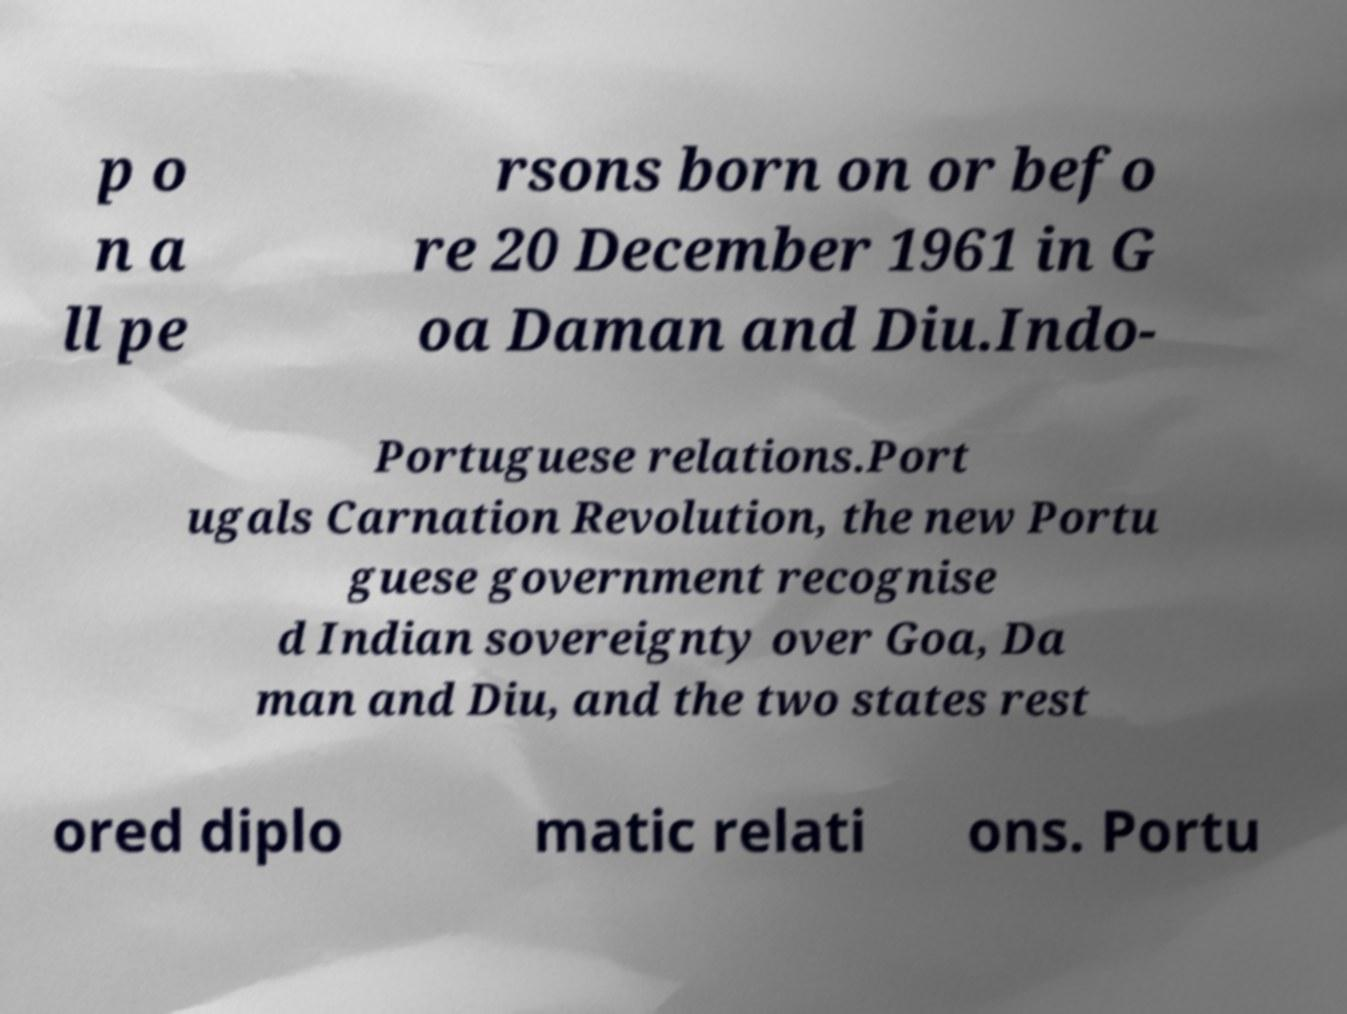I need the written content from this picture converted into text. Can you do that? p o n a ll pe rsons born on or befo re 20 December 1961 in G oa Daman and Diu.Indo- Portuguese relations.Port ugals Carnation Revolution, the new Portu guese government recognise d Indian sovereignty over Goa, Da man and Diu, and the two states rest ored diplo matic relati ons. Portu 